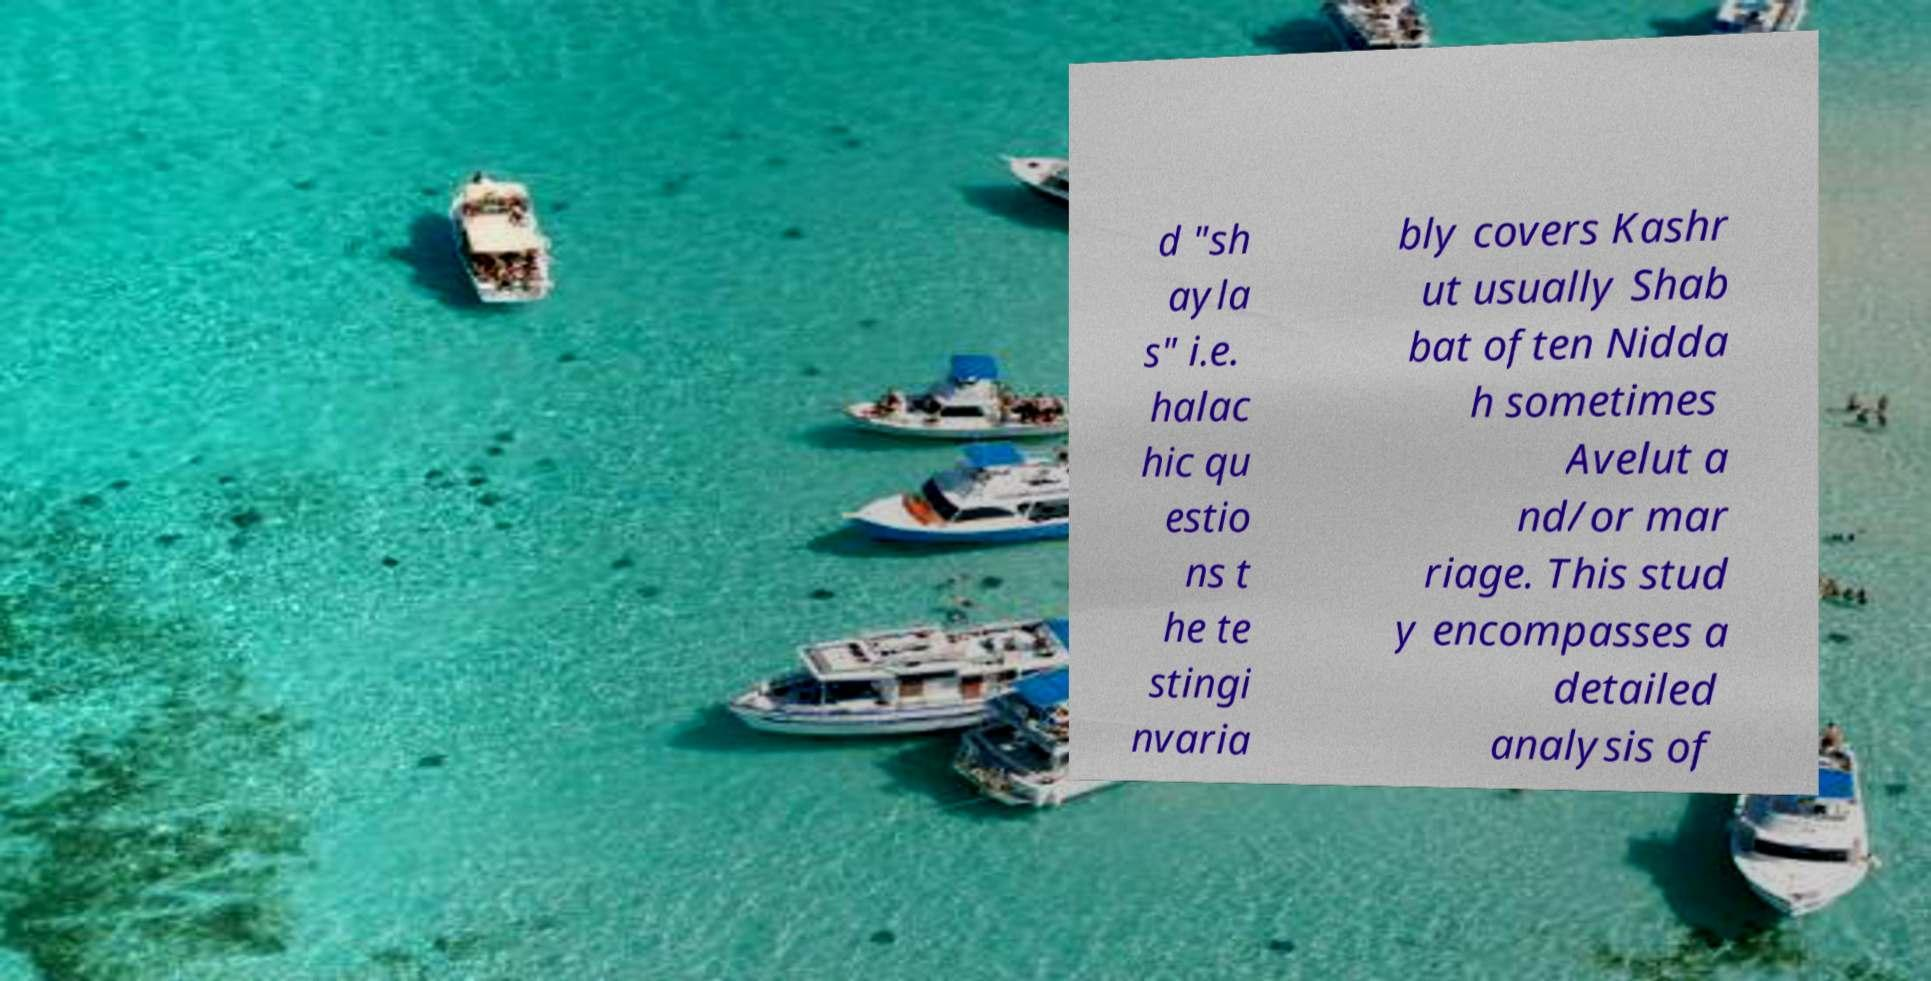Can you read and provide the text displayed in the image?This photo seems to have some interesting text. Can you extract and type it out for me? d "sh ayla s" i.e. halac hic qu estio ns t he te stingi nvaria bly covers Kashr ut usually Shab bat often Nidda h sometimes Avelut a nd/or mar riage. This stud y encompasses a detailed analysis of 